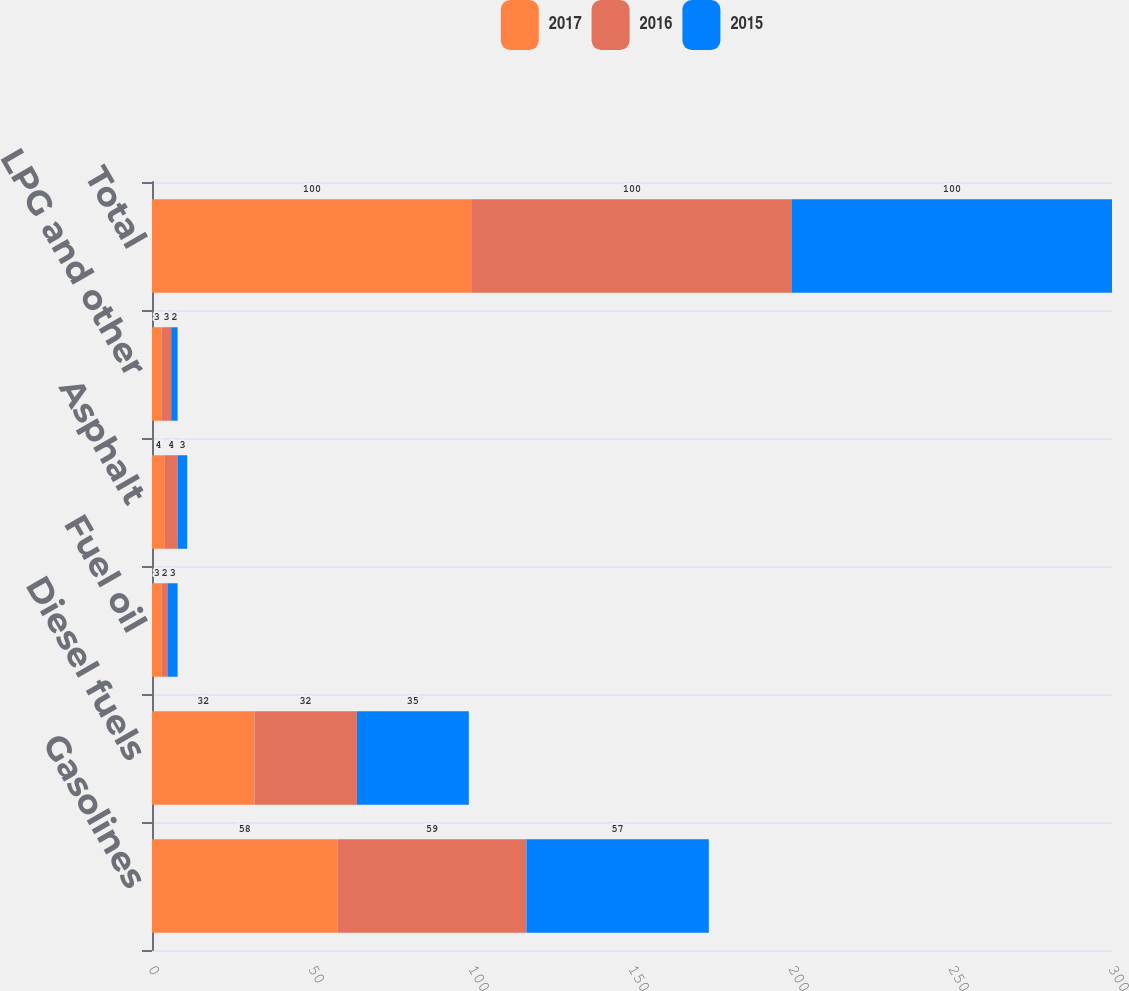Convert chart to OTSL. <chart><loc_0><loc_0><loc_500><loc_500><stacked_bar_chart><ecel><fcel>Gasolines<fcel>Diesel fuels<fcel>Fuel oil<fcel>Asphalt<fcel>LPG and other<fcel>Total<nl><fcel>2017<fcel>58<fcel>32<fcel>3<fcel>4<fcel>3<fcel>100<nl><fcel>2016<fcel>59<fcel>32<fcel>2<fcel>4<fcel>3<fcel>100<nl><fcel>2015<fcel>57<fcel>35<fcel>3<fcel>3<fcel>2<fcel>100<nl></chart> 